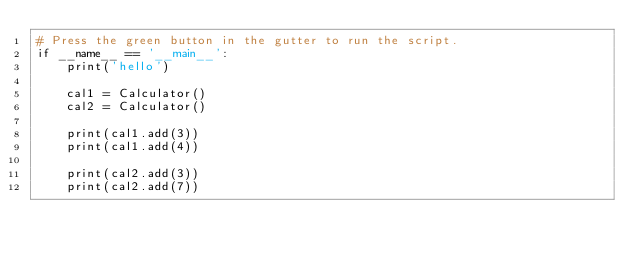Convert code to text. <code><loc_0><loc_0><loc_500><loc_500><_Python_># Press the green button in the gutter to run the script.
if __name__ == '__main__':
    print('hello')

    cal1 = Calculator()
    cal2 = Calculator()

    print(cal1.add(3))
    print(cal1.add(4))

    print(cal2.add(3))
    print(cal2.add(7))
</code> 